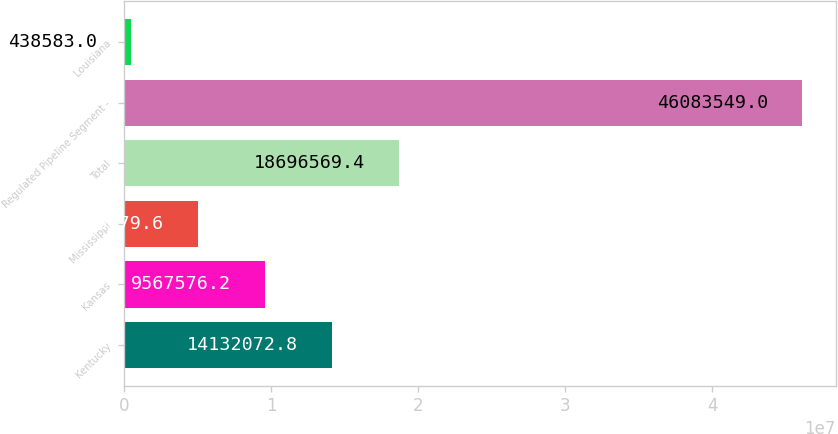Convert chart. <chart><loc_0><loc_0><loc_500><loc_500><bar_chart><fcel>Kentucky<fcel>Kansas<fcel>Mississippi<fcel>Total<fcel>Regulated Pipeline Segment -<fcel>Louisiana<nl><fcel>1.41321e+07<fcel>9.56758e+06<fcel>5.00308e+06<fcel>1.86966e+07<fcel>4.60835e+07<fcel>438583<nl></chart> 